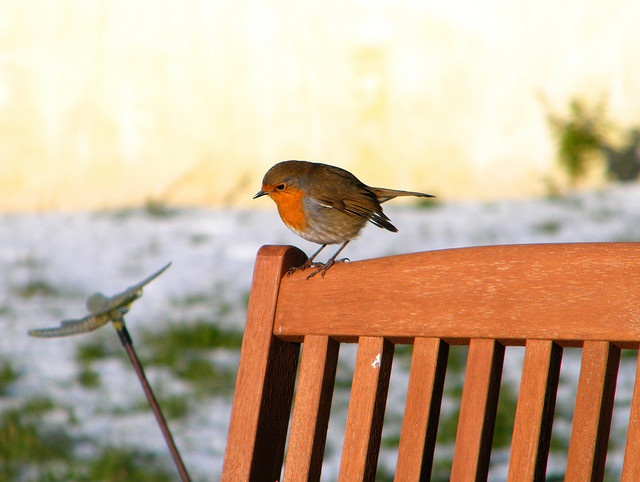Describe the objects in this image and their specific colors. I can see chair in ivory, red, salmon, and black tones, bench in ivory, red, salmon, and black tones, and bird in ivory, maroon, brown, and black tones in this image. 